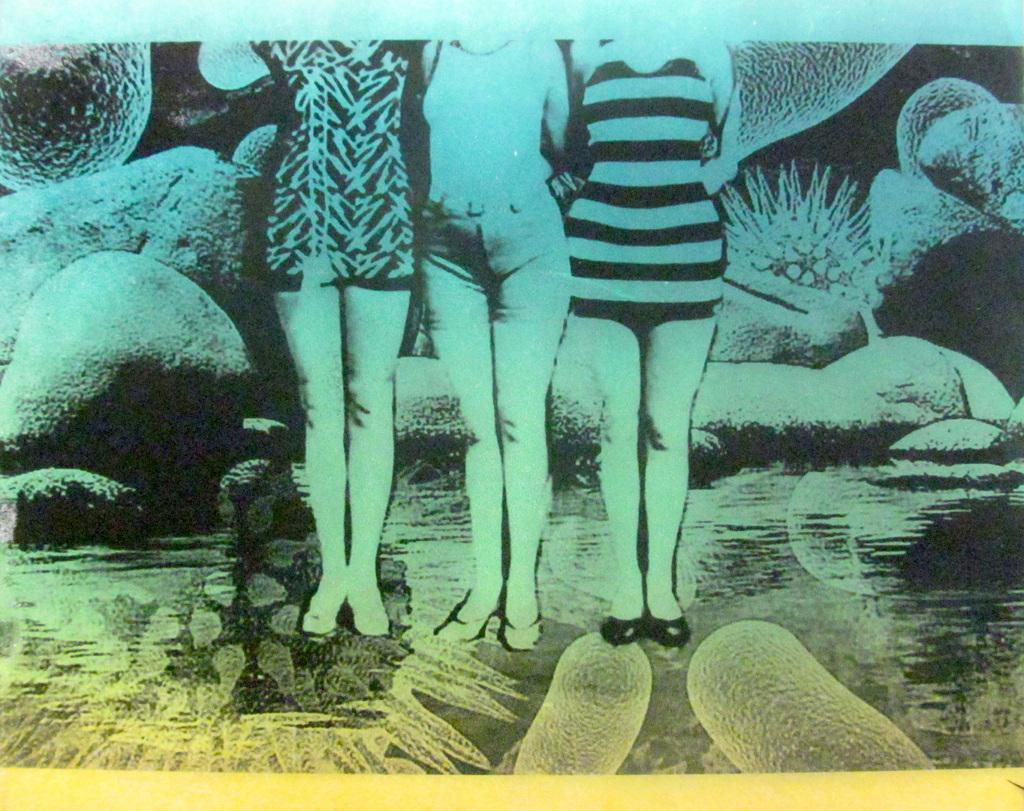How would you summarize this image in a sentence or two? This is an edited image, we can see three persons standing and in the background we can see some rocks. 